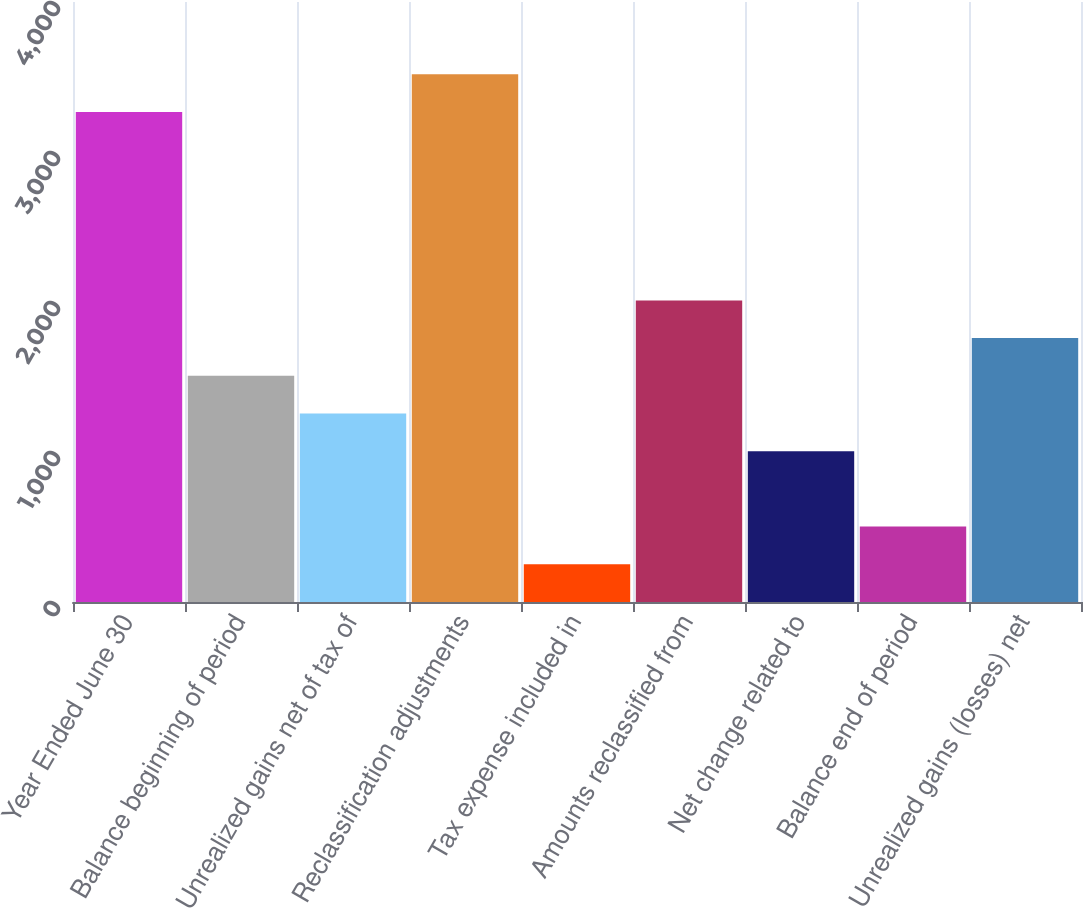Convert chart. <chart><loc_0><loc_0><loc_500><loc_500><bar_chart><fcel>Year Ended June 30<fcel>Balance beginning of period<fcel>Unrealized gains net of tax of<fcel>Reclassification adjustments<fcel>Tax expense included in<fcel>Amounts reclassified from<fcel>Net change related to<fcel>Balance end of period<fcel>Unrealized gains (losses) net<nl><fcel>3266.85<fcel>1507.96<fcel>1256.69<fcel>3518.12<fcel>251.61<fcel>2010.5<fcel>1005.42<fcel>502.88<fcel>1759.23<nl></chart> 